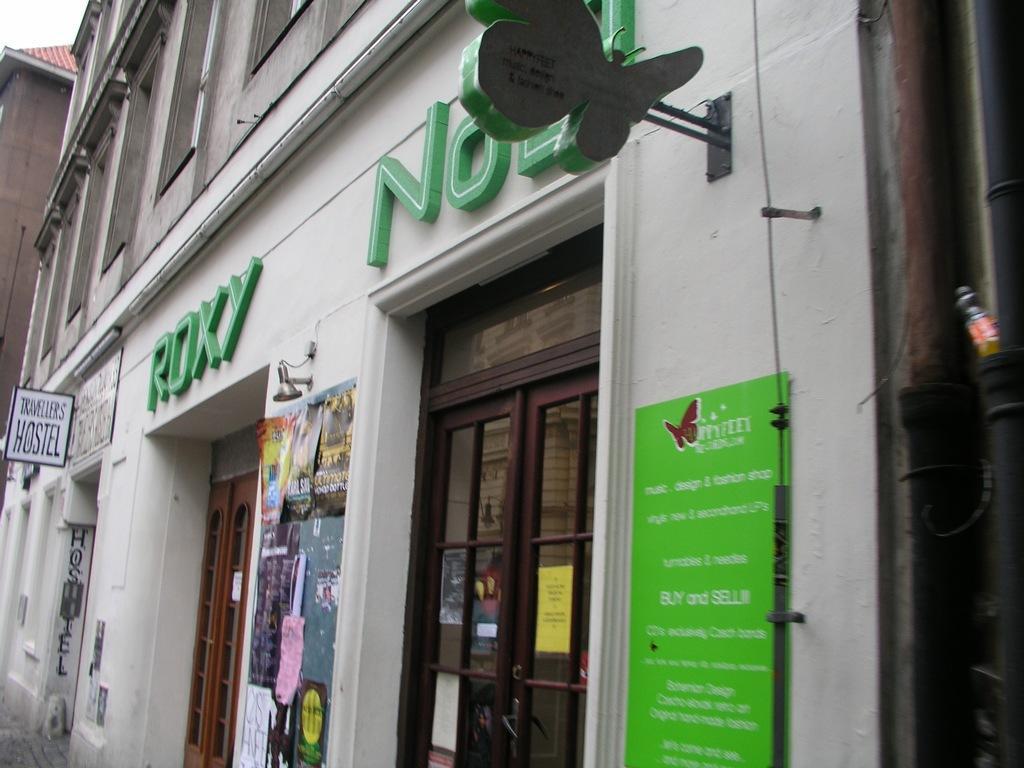Can you describe this image briefly? In this image we can see buildings. There are boards with some text. 